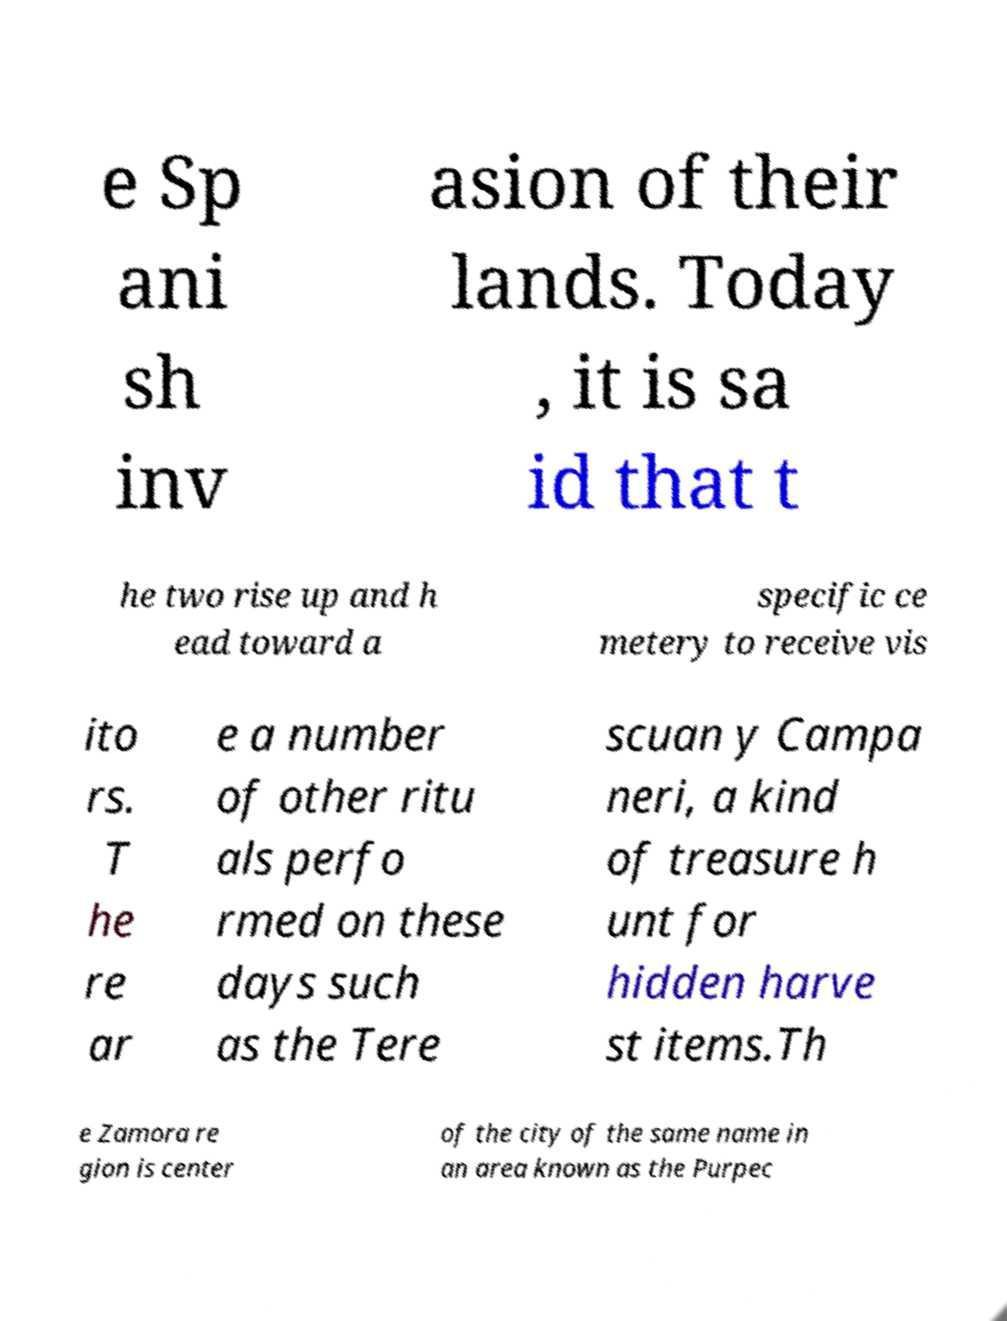Can you accurately transcribe the text from the provided image for me? e Sp ani sh inv asion of their lands. Today , it is sa id that t he two rise up and h ead toward a specific ce metery to receive vis ito rs. T he re ar e a number of other ritu als perfo rmed on these days such as the Tere scuan y Campa neri, a kind of treasure h unt for hidden harve st items.Th e Zamora re gion is center of the city of the same name in an area known as the Purpec 